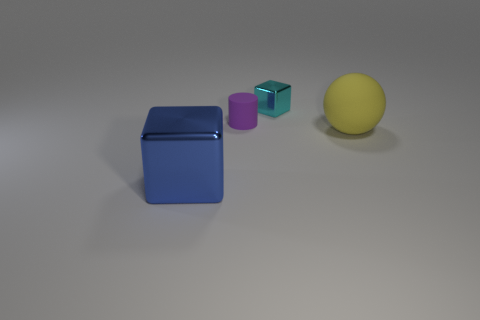Add 1 small matte cylinders. How many objects exist? 5 Subtract all cylinders. How many objects are left? 3 Subtract all small brown rubber blocks. Subtract all small purple rubber cylinders. How many objects are left? 3 Add 1 blue blocks. How many blue blocks are left? 2 Add 2 green matte blocks. How many green matte blocks exist? 2 Subtract 0 green cubes. How many objects are left? 4 